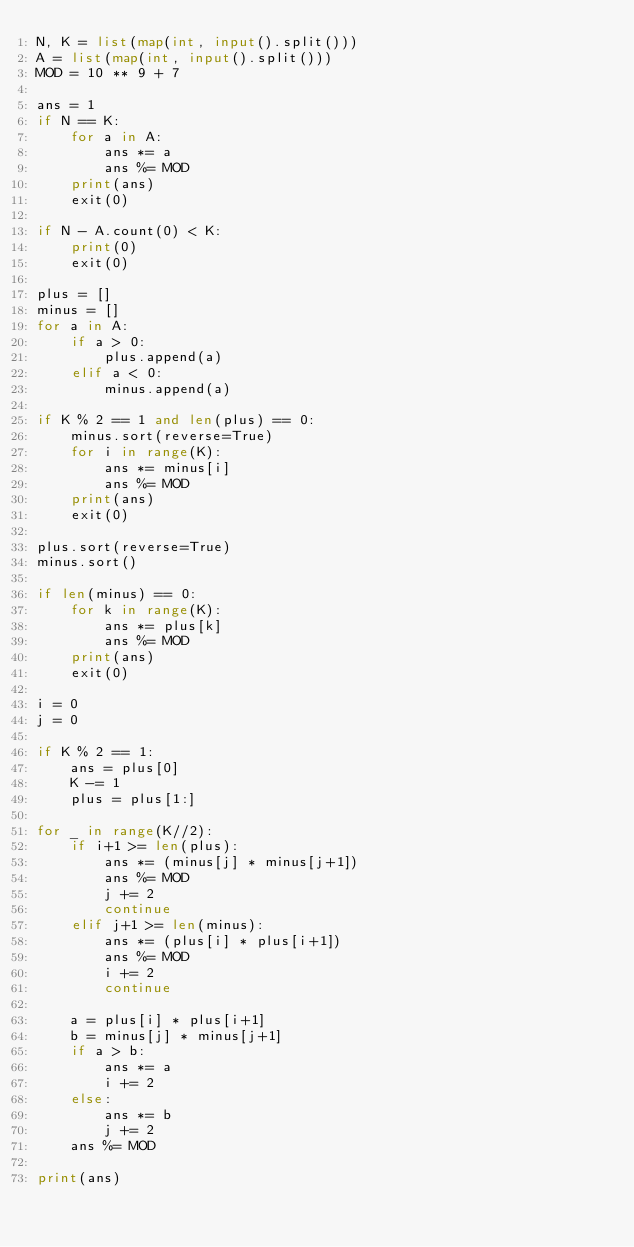<code> <loc_0><loc_0><loc_500><loc_500><_Python_>N, K = list(map(int, input().split()))
A = list(map(int, input().split()))
MOD = 10 ** 9 + 7

ans = 1
if N == K:
    for a in A:
        ans *= a
        ans %= MOD
    print(ans)
    exit(0)

if N - A.count(0) < K:
    print(0)
    exit(0)

plus = []
minus = []
for a in A:
    if a > 0:
        plus.append(a)
    elif a < 0:
        minus.append(a)

if K % 2 == 1 and len(plus) == 0:
    minus.sort(reverse=True)
    for i in range(K):
        ans *= minus[i]
        ans %= MOD
    print(ans)
    exit(0)

plus.sort(reverse=True)
minus.sort()

if len(minus) == 0:
    for k in range(K):
        ans *= plus[k]
        ans %= MOD
    print(ans)
    exit(0)

i = 0
j = 0

if K % 2 == 1:
    ans = plus[0]
    K -= 1
    plus = plus[1:]

for _ in range(K//2):
    if i+1 >= len(plus):
        ans *= (minus[j] * minus[j+1])
        ans %= MOD
        j += 2
        continue
    elif j+1 >= len(minus):
        ans *= (plus[i] * plus[i+1])
        ans %= MOD
        i += 2
        continue

    a = plus[i] * plus[i+1]
    b = minus[j] * minus[j+1]
    if a > b:
        ans *= a
        i += 2
    else:
        ans *= b
        j += 2
    ans %= MOD

print(ans)
</code> 